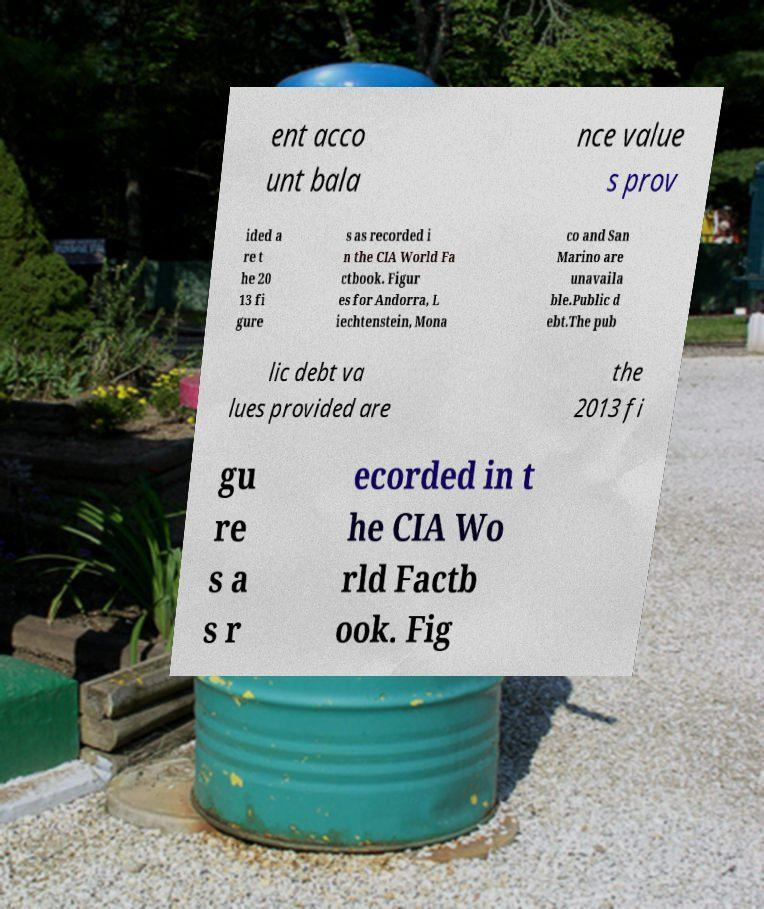For documentation purposes, I need the text within this image transcribed. Could you provide that? ent acco unt bala nce value s prov ided a re t he 20 13 fi gure s as recorded i n the CIA World Fa ctbook. Figur es for Andorra, L iechtenstein, Mona co and San Marino are unavaila ble.Public d ebt.The pub lic debt va lues provided are the 2013 fi gu re s a s r ecorded in t he CIA Wo rld Factb ook. Fig 